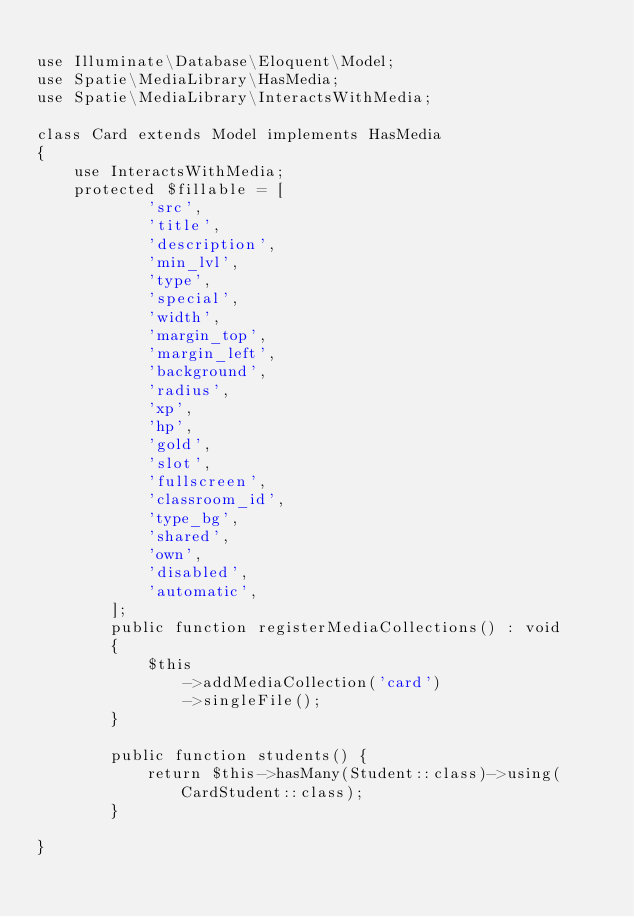Convert code to text. <code><loc_0><loc_0><loc_500><loc_500><_PHP_>
use Illuminate\Database\Eloquent\Model;
use Spatie\MediaLibrary\HasMedia;
use Spatie\MediaLibrary\InteractsWithMedia;

class Card extends Model implements HasMedia
{
    use InteractsWithMedia;
    protected $fillable = [ 
            'src', 
            'title',
            'description',
            'min_lvl',
            'type',
            'special',
            'width',
            'margin_top',
            'margin_left',
            'background',
            'radius',
            'xp',
            'hp',
            'gold',
            'slot',
            'fullscreen',
            'classroom_id',
            'type_bg',
            'shared',
            'own',
            'disabled',
            'automatic',
        ];
        public function registerMediaCollections() : void 
        {
            $this
                ->addMediaCollection('card')
                ->singleFile();
        }

        public function students() {
            return $this->hasMany(Student::class)->using(CardStudent::class);
        }

}
</code> 